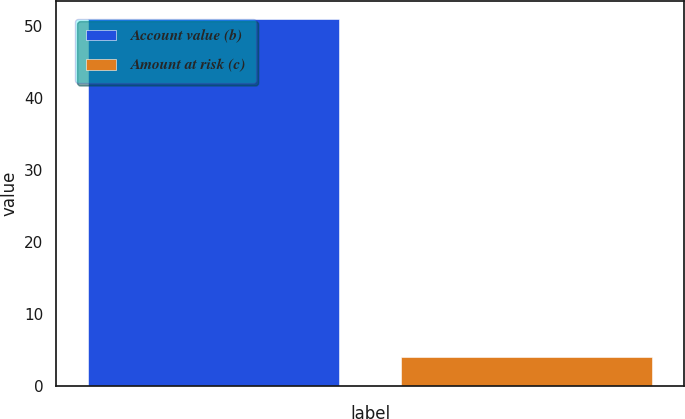Convert chart to OTSL. <chart><loc_0><loc_0><loc_500><loc_500><bar_chart><fcel>Account value (b)<fcel>Amount at risk (c)<nl><fcel>51<fcel>4<nl></chart> 